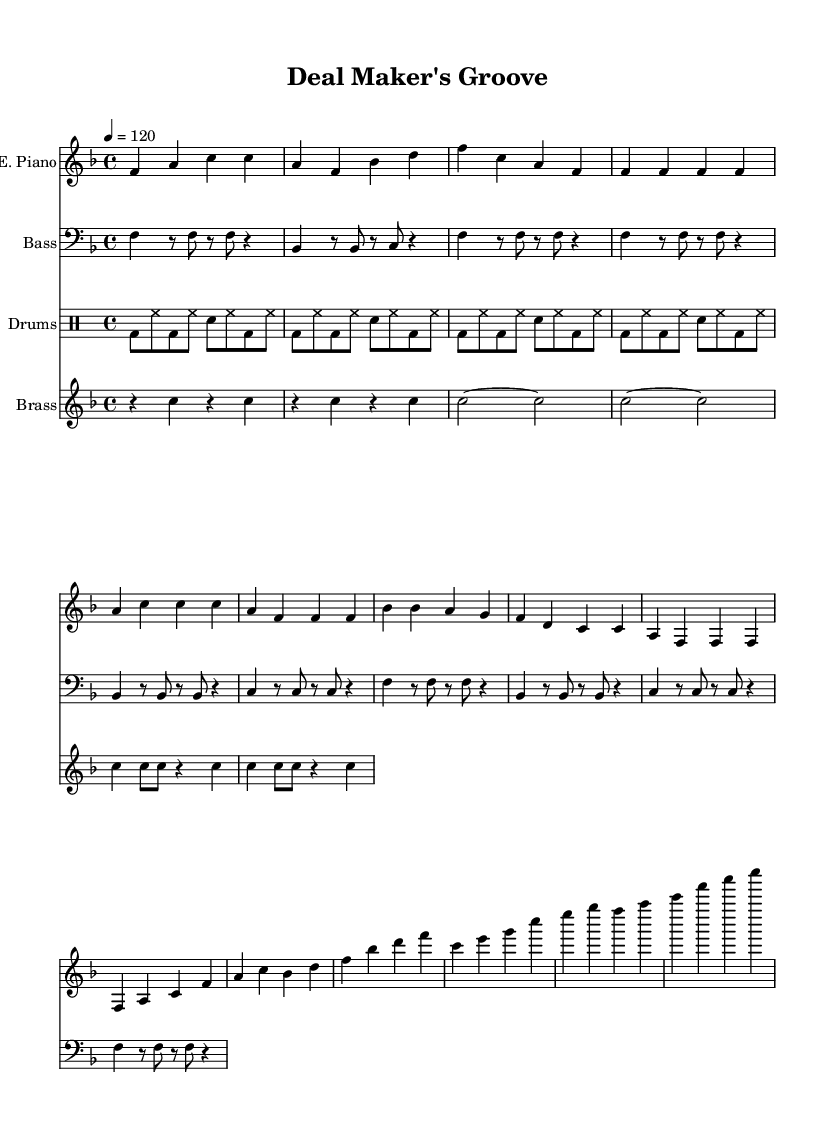What is the key signature of this music? The key signature appears at the beginning of the score marked with a flat symbol, indicating that the piece is in F major, which has one flat (B flat).
Answer: F major What is the time signature of this music? The time signature is marked at the beginning of the score and shows a four over four, indicating that there are four beats in each measure, which is typical for funk music.
Answer: 4/4 What is the tempo marked in this sheet music? The tempo is indicated at the start of the score with a marking of "4 = 120," which specifies the number of beats per minute for the piece.
Answer: 120 How many measures are there in the introductory section for the electric piano? By counting the distinct segments in the electric piano part labeled as "Intro," we find that there are 8 measures present.
Answer: 8 Which instrument primarily plays the melody in this piece? The melody is mainly played by the electric piano, which is indicated as the first instrument in the score, featuring melodic lines in the treble clef.
Answer: Electric Piano What rhythmic pattern do the drums predominantly use? The drums display a consistent basic funk pattern characterized by bass and snare hits interspersed with hi-hat, ensuring a regular groove throughout the measures.
Answer: Funk pattern What section of the music corresponds to the "Chorus"? The "Chorus" is indicated in the sheet music, identifiable by specific phrases and a shift in the musical dynamics; visually, it follows the "Verse" and is made up of corresponding measures.
Answer: Chorus 